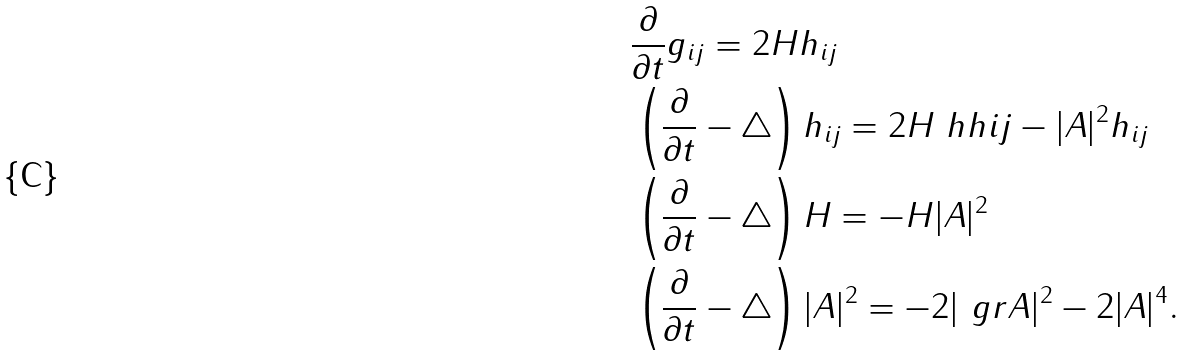<formula> <loc_0><loc_0><loc_500><loc_500>& \frac { \partial } { \partial t } g _ { i j } = 2 H h _ { i j } \\ & \left ( \frac { \partial } { \partial t } - \triangle \right ) h _ { i j } = 2 H \ h h { i } { j } - | A | ^ { 2 } h _ { i j } \\ & \left ( \frac { \partial } { \partial t } - \triangle \right ) H = - H | A | ^ { 2 } \\ & \left ( \frac { \partial } { \partial t } - \triangle \right ) | A | ^ { 2 } = - 2 | \ g r A | ^ { 2 } - 2 | A | ^ { 4 } .</formula> 